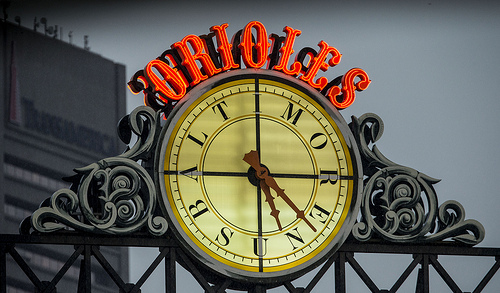What does the text above the clock signify? The glowing red text above the clock spells out 'Orioles,' which likely refers to the Baltimore Orioles, a Major League Baseball team. 